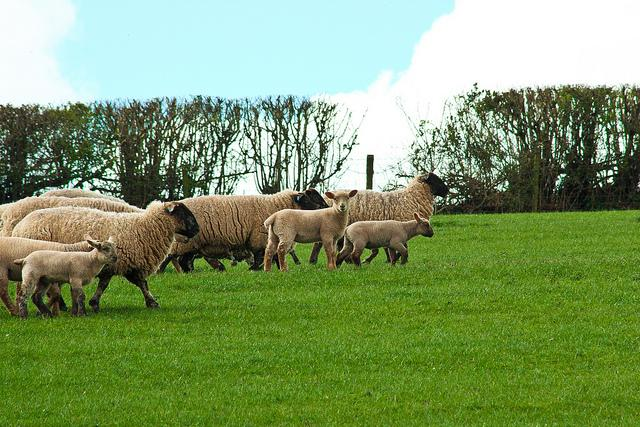Why are some of the animals smaller than other? babies 